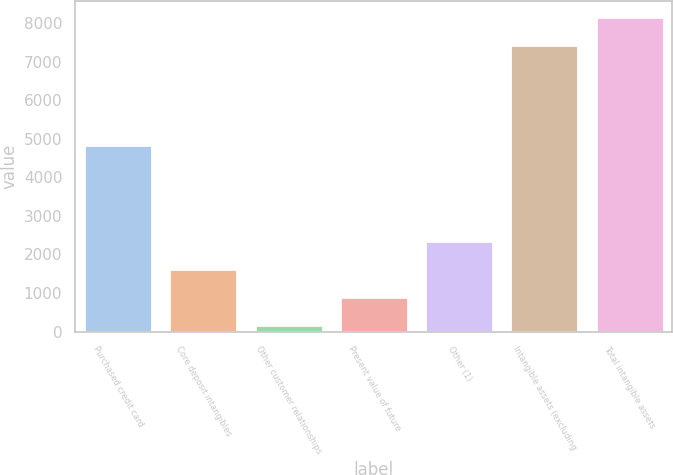Convert chart. <chart><loc_0><loc_0><loc_500><loc_500><bar_chart><fcel>Purchased credit card<fcel>Core deposit intangibles<fcel>Other customer relationships<fcel>Present value of future<fcel>Other (1)<fcel>Intangible assets (excluding<fcel>Total intangible assets<nl><fcel>4838<fcel>1630<fcel>176<fcel>903<fcel>2357<fcel>7446<fcel>8173<nl></chart> 